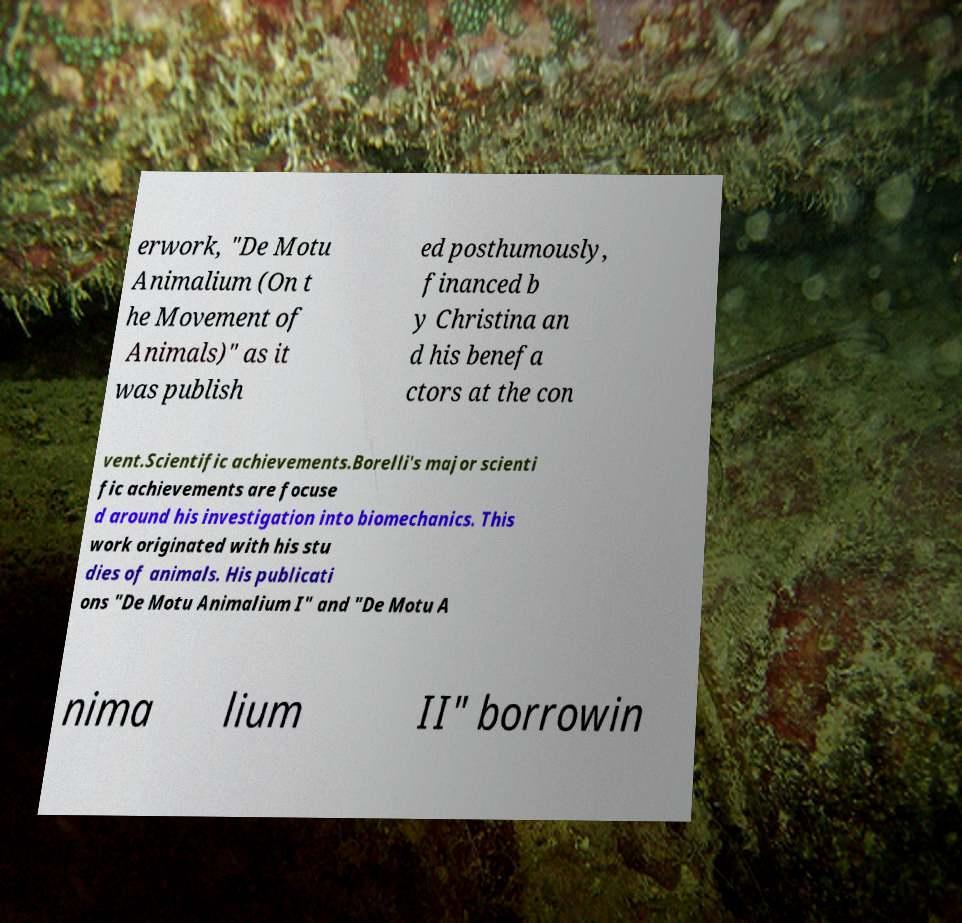Could you assist in decoding the text presented in this image and type it out clearly? erwork, "De Motu Animalium (On t he Movement of Animals)" as it was publish ed posthumously, financed b y Christina an d his benefa ctors at the con vent.Scientific achievements.Borelli's major scienti fic achievements are focuse d around his investigation into biomechanics. This work originated with his stu dies of animals. His publicati ons "De Motu Animalium I" and "De Motu A nima lium II" borrowin 